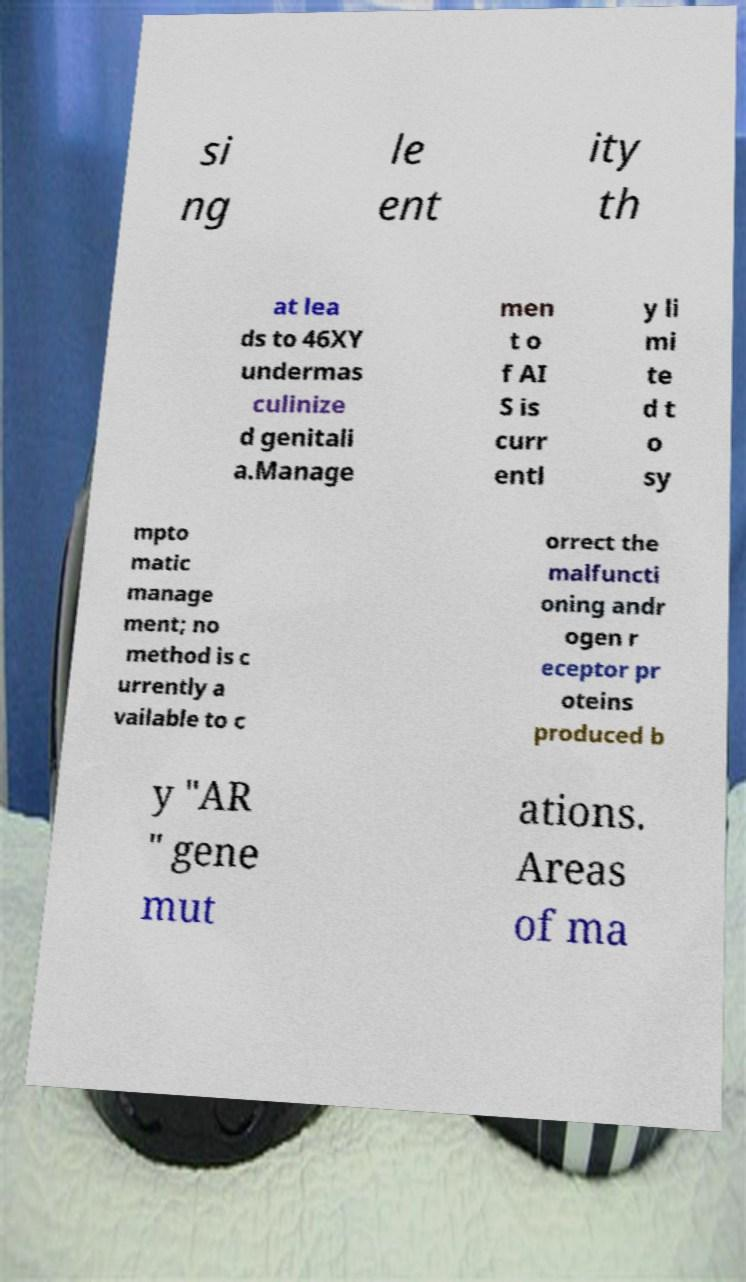What messages or text are displayed in this image? I need them in a readable, typed format. si ng le ent ity th at lea ds to 46XY undermas culinize d genitali a.Manage men t o f AI S is curr entl y li mi te d t o sy mpto matic manage ment; no method is c urrently a vailable to c orrect the malfuncti oning andr ogen r eceptor pr oteins produced b y "AR " gene mut ations. Areas of ma 